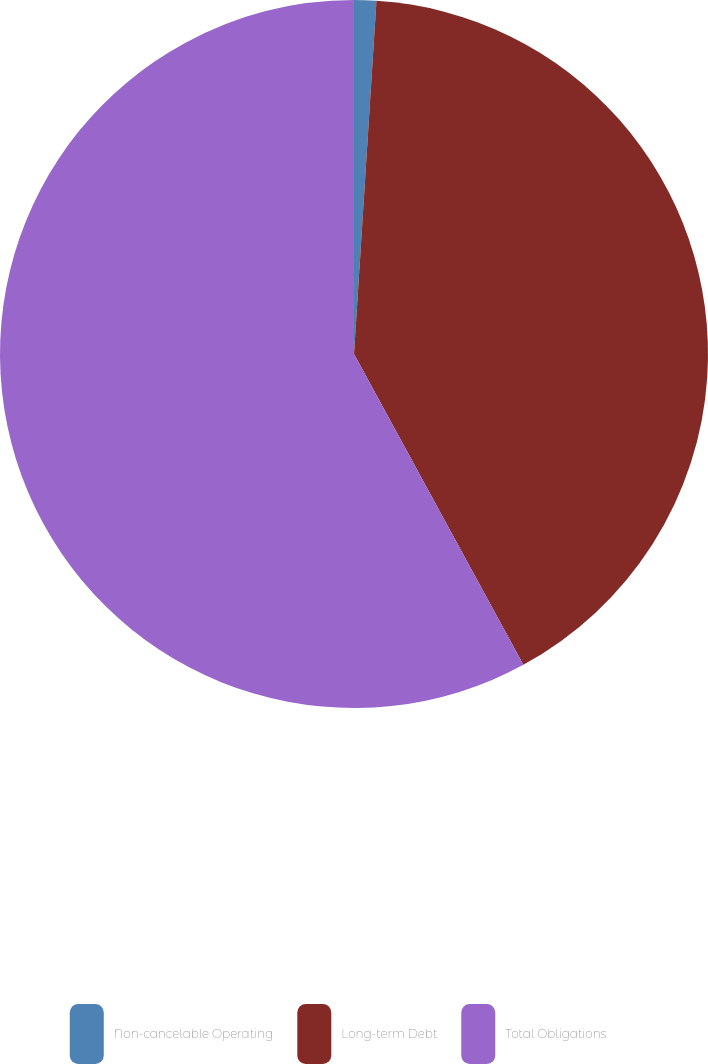Convert chart. <chart><loc_0><loc_0><loc_500><loc_500><pie_chart><fcel>Non-cancelable Operating<fcel>Long-term Debt<fcel>Total Obligations<nl><fcel>1.01%<fcel>41.05%<fcel>57.94%<nl></chart> 